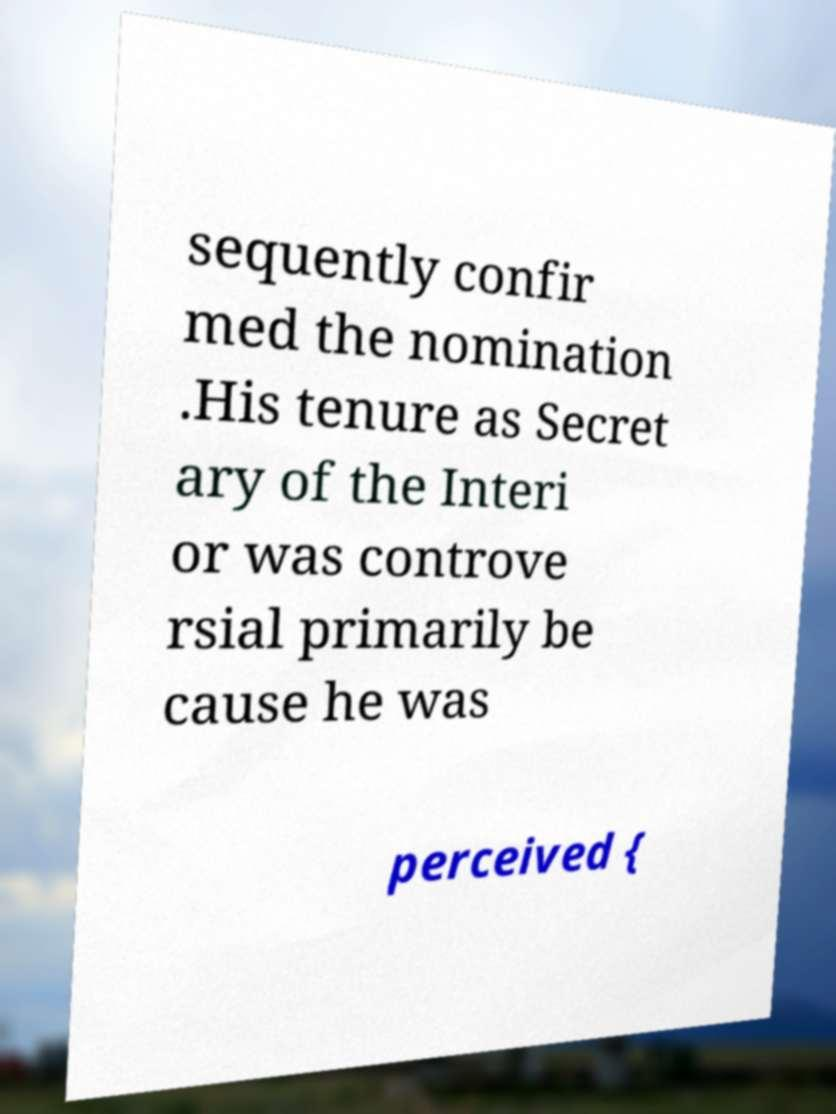Can you accurately transcribe the text from the provided image for me? sequently confir med the nomination .His tenure as Secret ary of the Interi or was controve rsial primarily be cause he was perceived { 